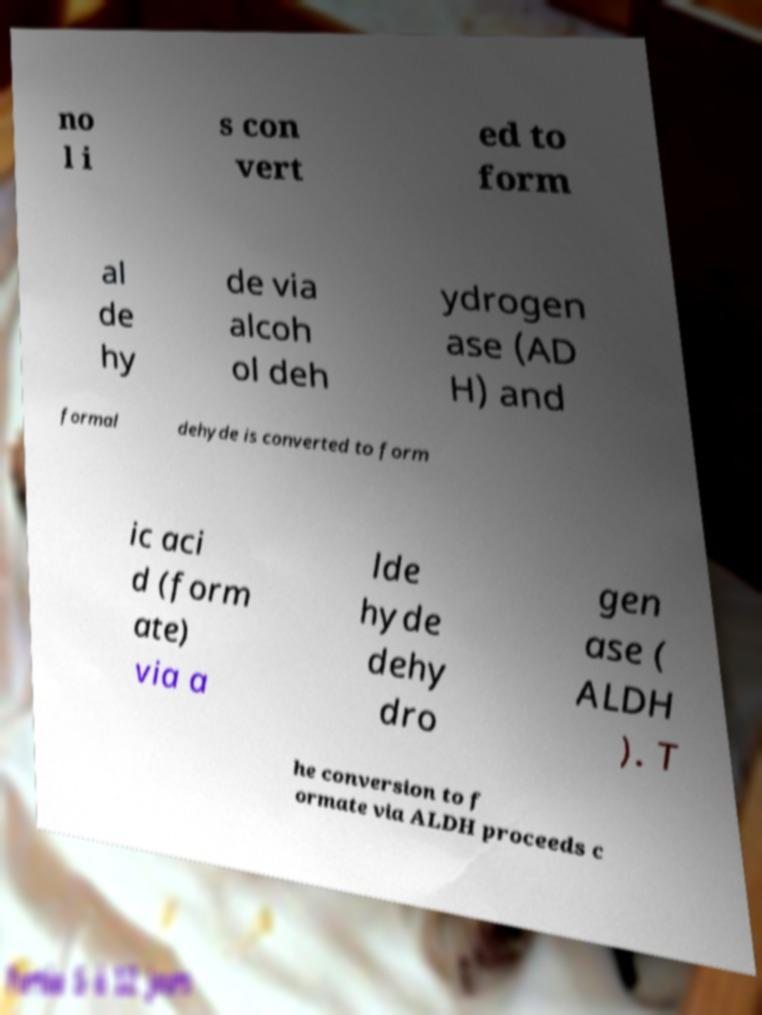I need the written content from this picture converted into text. Can you do that? no l i s con vert ed to form al de hy de via alcoh ol deh ydrogen ase (AD H) and formal dehyde is converted to form ic aci d (form ate) via a lde hyde dehy dro gen ase ( ALDH ). T he conversion to f ormate via ALDH proceeds c 